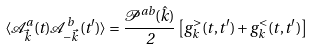Convert formula to latex. <formula><loc_0><loc_0><loc_500><loc_500>\langle \mathcal { A } ^ { a } _ { \vec { k } } ( t ) \mathcal { A } ^ { b } _ { - \vec { k } } ( t ^ { \prime } ) \rangle = \frac { \mathcal { P } ^ { a b } ( \hat { k } ) } { 2 } \left [ g ^ { > } _ { k } ( t , t ^ { \prime } ) + g ^ { < } _ { k } ( t , t ^ { \prime } ) \right ]</formula> 